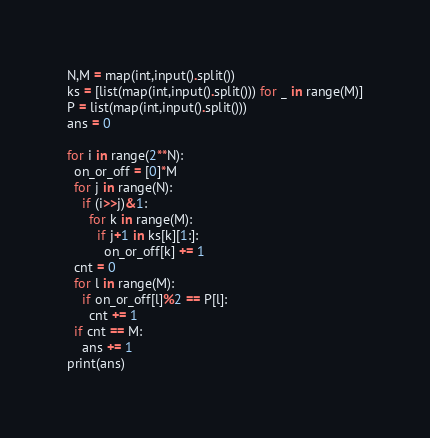Convert code to text. <code><loc_0><loc_0><loc_500><loc_500><_Python_>N,M = map(int,input().split())
ks = [list(map(int,input().split())) for _ in range(M)]
P = list(map(int,input().split()))
ans = 0

for i in range(2**N):
  on_or_off = [0]*M
  for j in range(N):
    if (i>>j)&1:
      for k in range(M):
        if j+1 in ks[k][1:]:
          on_or_off[k] += 1
  cnt = 0
  for l in range(M):
    if on_or_off[l]%2 == P[l]:
      cnt += 1
  if cnt == M:
    ans += 1
print(ans)</code> 